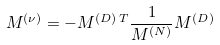Convert formula to latex. <formula><loc_0><loc_0><loc_500><loc_500>M ^ { ( \nu ) } = - M ^ { ( D ) \, T } \frac { 1 } { M ^ { ( N ) } } M ^ { ( D ) }</formula> 